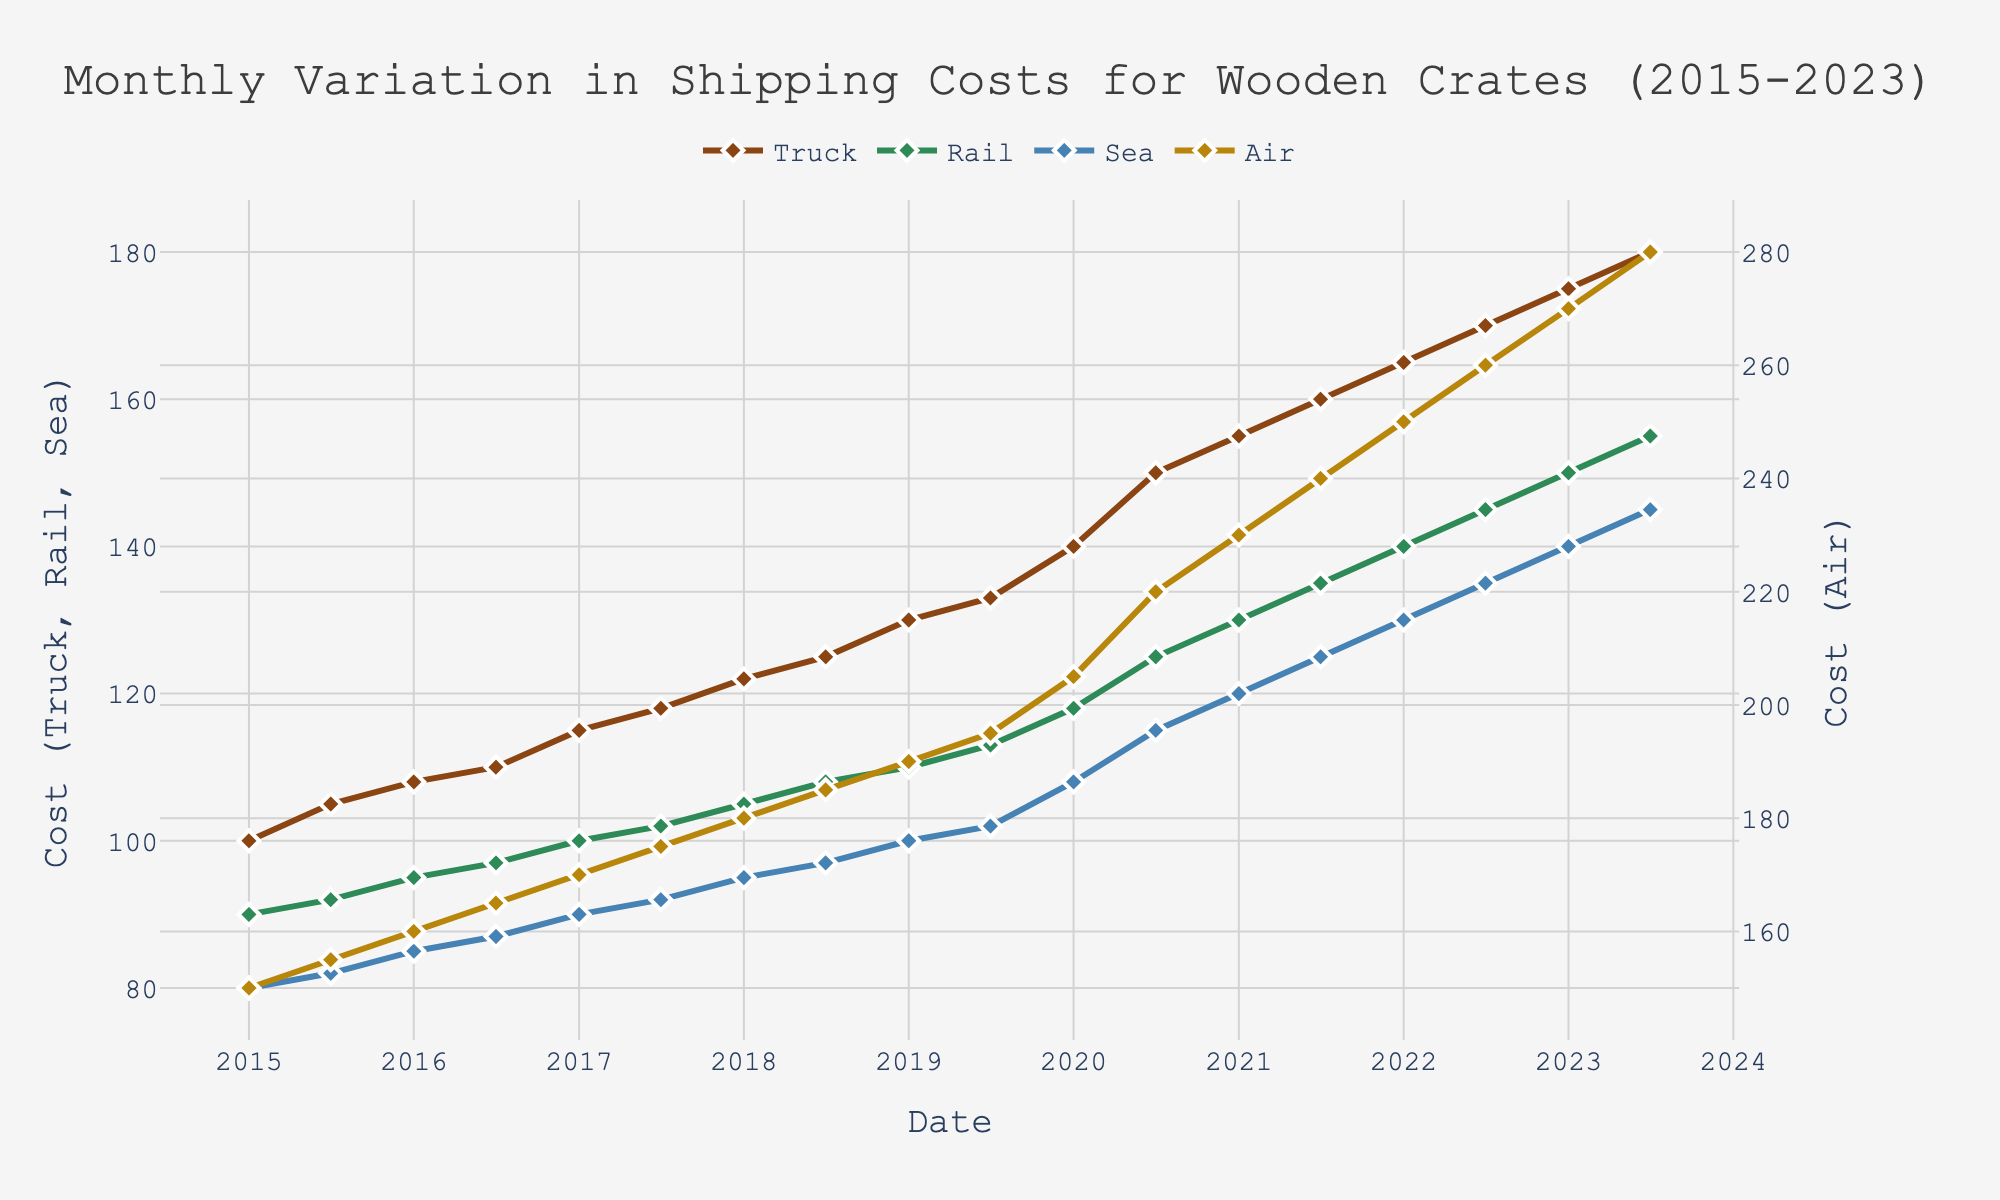What year shows the first notable increase in shipping costs? The graph indicates initial stability with minor increases until 2018 when costs across all transportation modes start rising more noticeably. Therefore, the first notable increase appears in the data point for 2018-01.
Answer: 2018 In which month and year did the shipping cost for air transportation reach $240? From the chart, the air transportation cost reached $240 in 2021-07. This is determined by following the air transportation trend line (colored golden brown) to where it meets the $240 mark on the y-axis and noting the corresponding date.
Answer: 2021-07 Which mode of transportation experienced the highest percentage increase in cost from 2015-01 to 2023-07? Calculate the percentage increase for each mode: 
Truck: ((180-100)/100) * 100 = 80%
Rail: ((155-90)/90) * 100 = 72.22%
Sea: ((145-80)/80) * 100 = 81.25%
Air: ((280-150)/150) * 100 = 86.67%
The air transportation mode shows the highest percentage increase.
Answer: Air What was the cost difference between Truck and Rail transportation in 2020-07? From the graph, the cost for Truck in 2020-07 is $150, and for Rail, it is $125. Subtract the Rail cost from the Truck cost to get the difference: $150 - $125 = $25.
Answer: $25 Which mode of transportation shows the most consistent rate of increase over the years? The Sea transportation costs have a relatively steady, almost linear increase over the years without any steep or rapid changes, indicating the most consistent rate of increase.
Answer: Sea How many times did the cost of sea transportation equal the cost of rail transportation exactly? By observing the graph, there is no point at which the costs for Sea and Rail transportation intersect or match exactly, indicating zero times.
Answer: 0 What is the total combined cost for all four transportation modes in 2019-01? Add the values of all four modes for 2019-01:
Truck: 130
Rail: 110
Sea: 100
Air: 190
Total = 130 + 110 + 100 + 190 = 530.
Answer: 530 Is there any month when the cost of Truck, Rail, and Sea are all equal to or greater than $140? Check the data points where all these modes meet or exceed $140. For instance, in 2022-07: Truck: 170, Rail: 145, Sea: 135 (Sea is less than $140). In 2023-01: Truck: 175, Rail: 150, Sea: 140 (all meet or exceed $140). Thus, 2023-01 is the month where all costs meet the criteria.
Answer: 2023-01 What trend can you observe for the air transportation cost from 2015 to 2023? The air transportation cost shows a steady increasing trend, with the cost starting at $150 in 2015 and rising continuously each year, reaching $280 in 2023. The increase appears linear and consistent.
Answer: Steady increase 